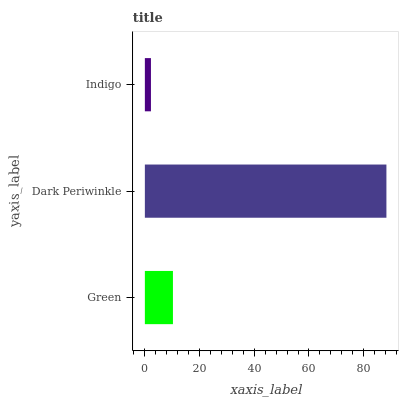Is Indigo the minimum?
Answer yes or no. Yes. Is Dark Periwinkle the maximum?
Answer yes or no. Yes. Is Dark Periwinkle the minimum?
Answer yes or no. No. Is Indigo the maximum?
Answer yes or no. No. Is Dark Periwinkle greater than Indigo?
Answer yes or no. Yes. Is Indigo less than Dark Periwinkle?
Answer yes or no. Yes. Is Indigo greater than Dark Periwinkle?
Answer yes or no. No. Is Dark Periwinkle less than Indigo?
Answer yes or no. No. Is Green the high median?
Answer yes or no. Yes. Is Green the low median?
Answer yes or no. Yes. Is Dark Periwinkle the high median?
Answer yes or no. No. Is Indigo the low median?
Answer yes or no. No. 